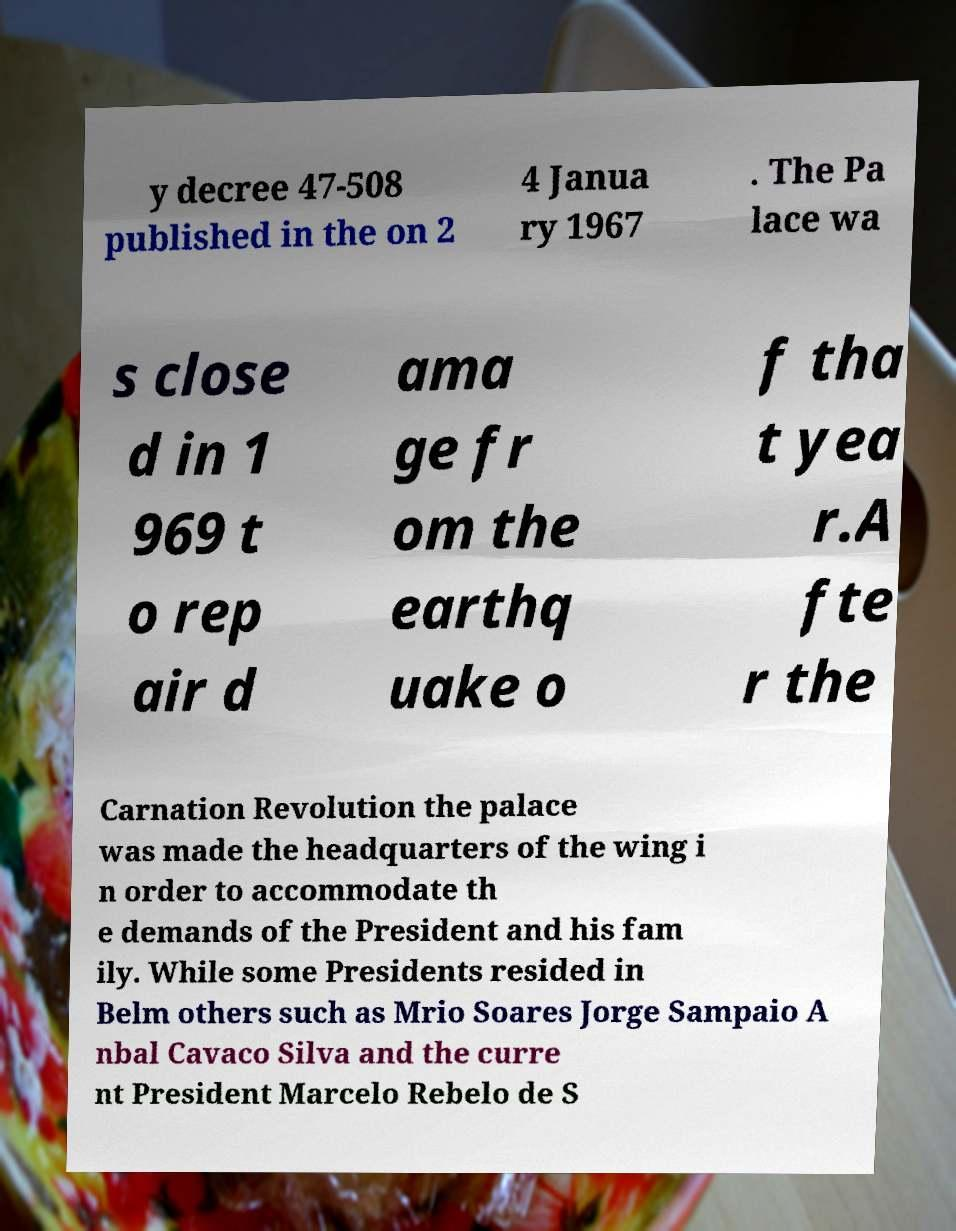Can you read and provide the text displayed in the image?This photo seems to have some interesting text. Can you extract and type it out for me? y decree 47-508 published in the on 2 4 Janua ry 1967 . The Pa lace wa s close d in 1 969 t o rep air d ama ge fr om the earthq uake o f tha t yea r.A fte r the Carnation Revolution the palace was made the headquarters of the wing i n order to accommodate th e demands of the President and his fam ily. While some Presidents resided in Belm others such as Mrio Soares Jorge Sampaio A nbal Cavaco Silva and the curre nt President Marcelo Rebelo de S 